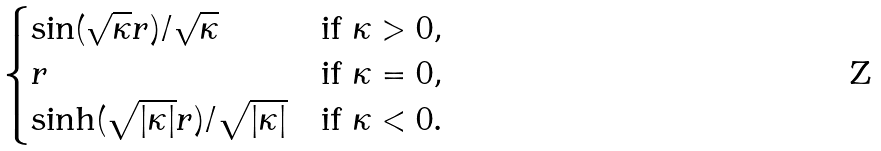Convert formula to latex. <formula><loc_0><loc_0><loc_500><loc_500>\begin{cases} \sin ( \sqrt { \kappa } r ) / \sqrt { \kappa } & \text {if $\kappa > 0$} , \\ r & \text {if $\kappa = 0$} , \\ \sinh ( \sqrt { | \kappa | } r ) / \sqrt { | \kappa | } & \text {if $\kappa < 0$} . \end{cases}</formula> 